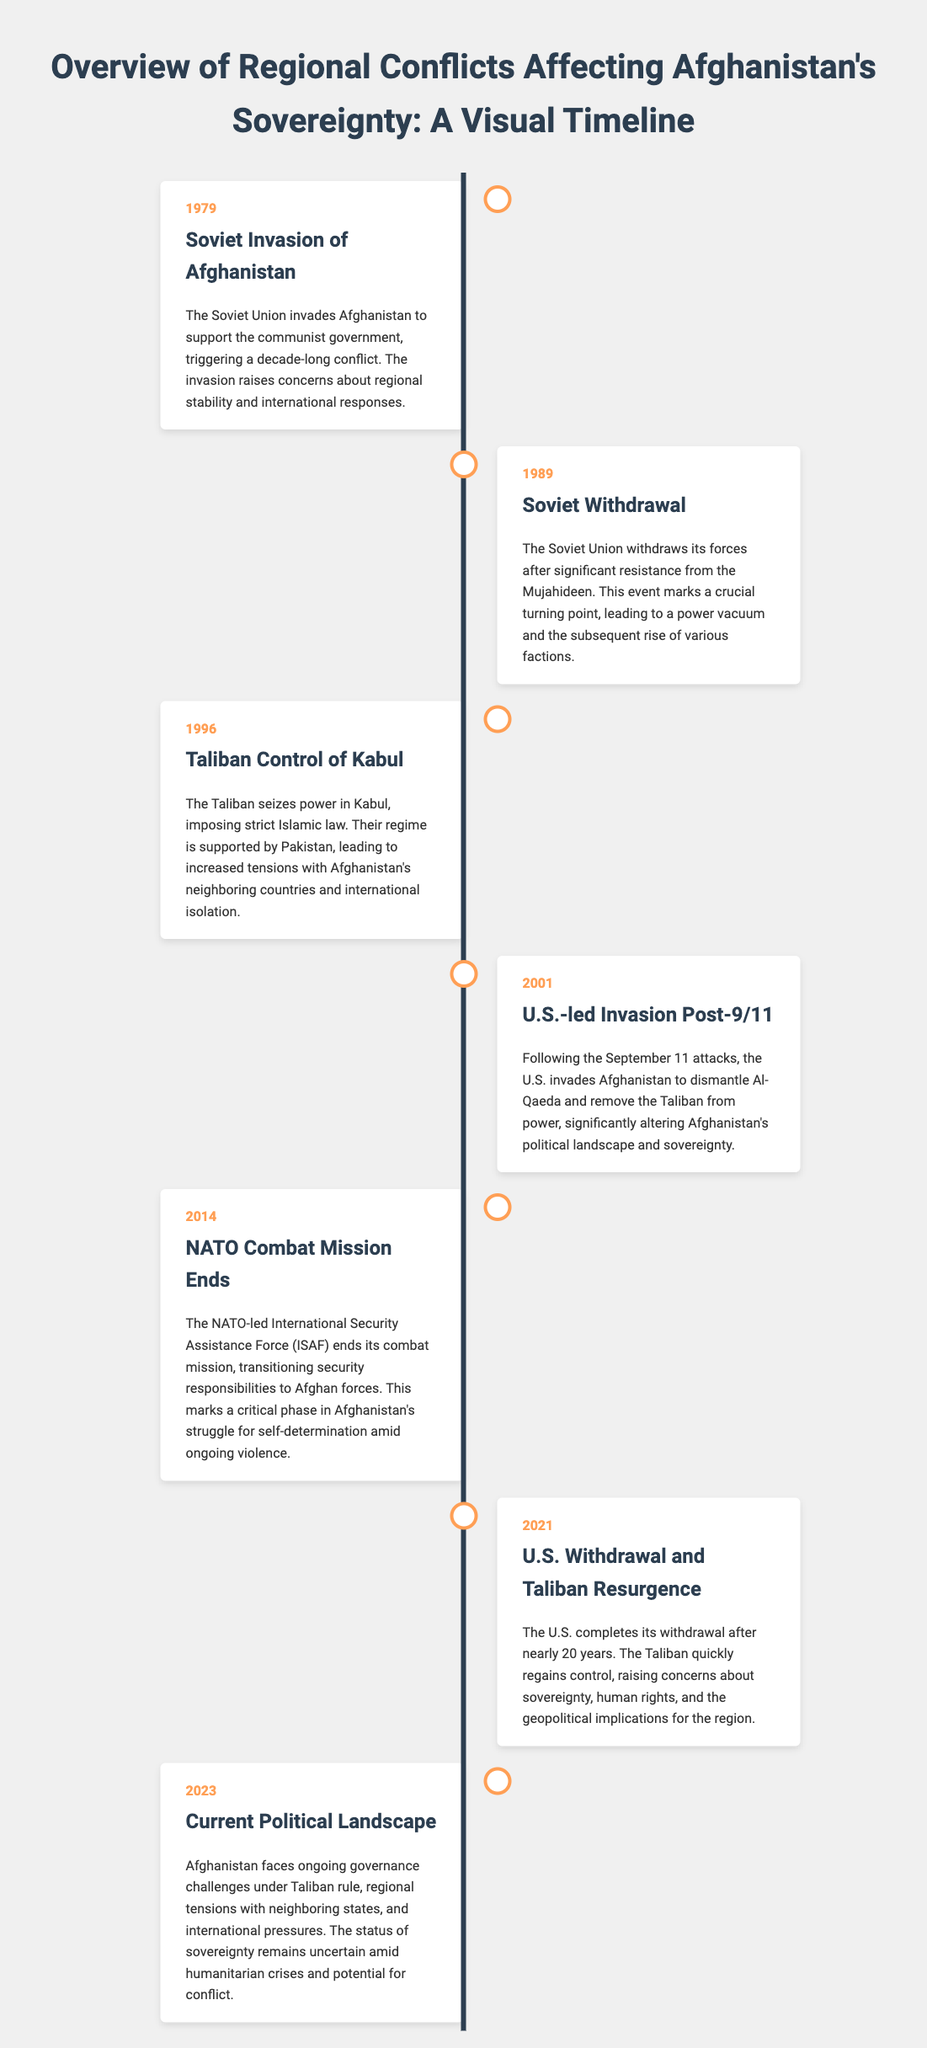what year did the Soviet invasion of Afghanistan occur? The document states that the Soviet invasion occurred in 1979.
Answer: 1979 who gained control of Kabul in 1996? According to the document, the Taliban seized control of Kabul in 1996.
Answer: Taliban what significant event happened in 2001? The document mentions that a U.S.-led invasion occurred in 2001 following the September 11 attacks.
Answer: U.S.-led invasion what marks the end of NATO's combat mission in Afghanistan? The document indicates that NATO's combat mission ended in 2014, transitioning security responsibilities to Afghan forces.
Answer: 2014 what was a major consequence of the 2021 U.S. withdrawal from Afghanistan? The document highlights that the Taliban quickly regained control after the U.S. withdrawal in 2021.
Answer: Taliban regained control how many years did the U.S. remain involved in Afghanistan? The document states that the U.S. was involved for nearly 20 years up until 2021.
Answer: Nearly 20 years what is the subject of the document? The document focuses on the overview of regional conflicts affecting Afghanistan's sovereignty.
Answer: Overview of regional conflicts what specific governance challenges does Afghanistan face as of 2023? The document notes ongoing governance challenges under Taliban rule in 2023.
Answer: Governance challenges what year marks the current political landscape mentioned in the document? The document identifies that the current political landscape is discussed in 2023.
Answer: 2023 